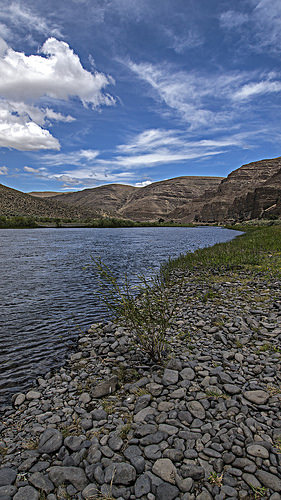<image>
Is the mountain behind the lake? Yes. From this viewpoint, the mountain is positioned behind the lake, with the lake partially or fully occluding the mountain. 